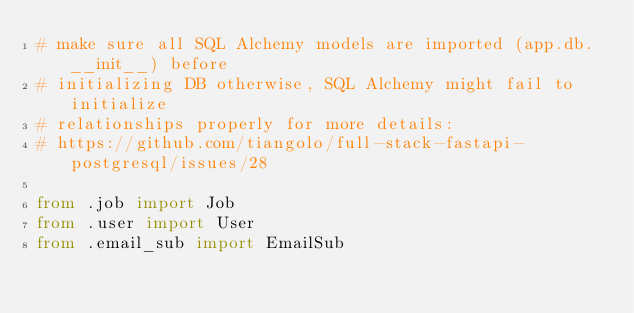Convert code to text. <code><loc_0><loc_0><loc_500><loc_500><_Python_># make sure all SQL Alchemy models are imported (app.db.__init__) before
# initializing DB otherwise, SQL Alchemy might fail to initialize
# relationships properly for more details:
# https://github.com/tiangolo/full-stack-fastapi-postgresql/issues/28

from .job import Job
from .user import User
from .email_sub import EmailSub
</code> 